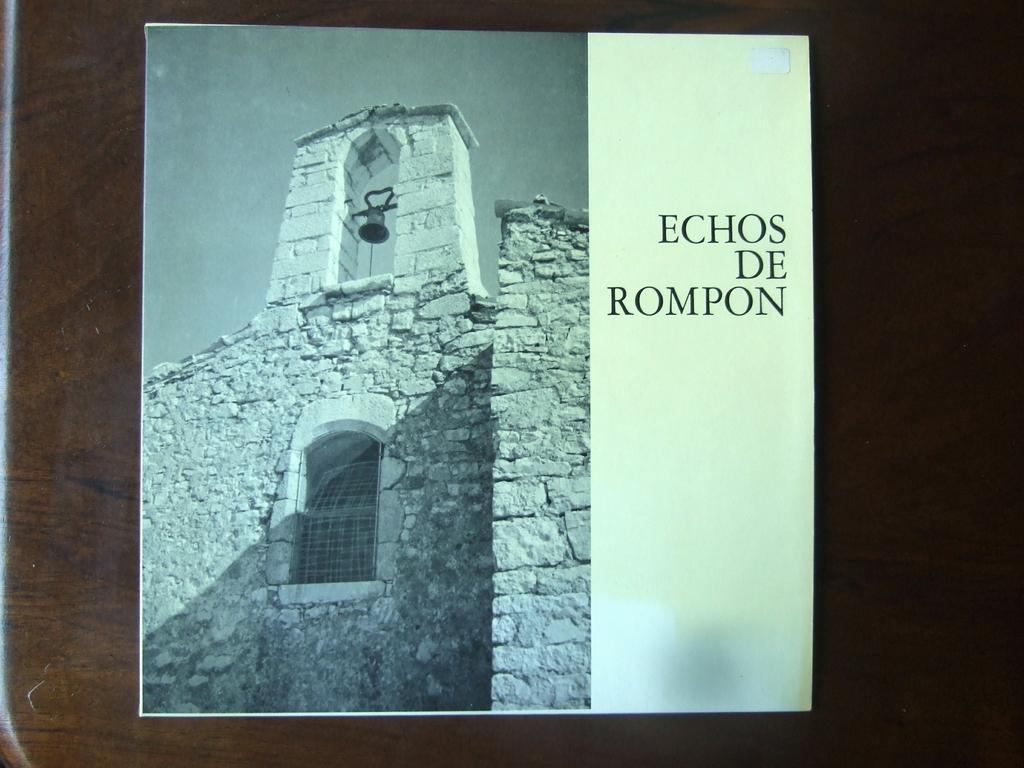<image>
Describe the image concisely. A poster for Echos De Rompon sits on a wooden table 